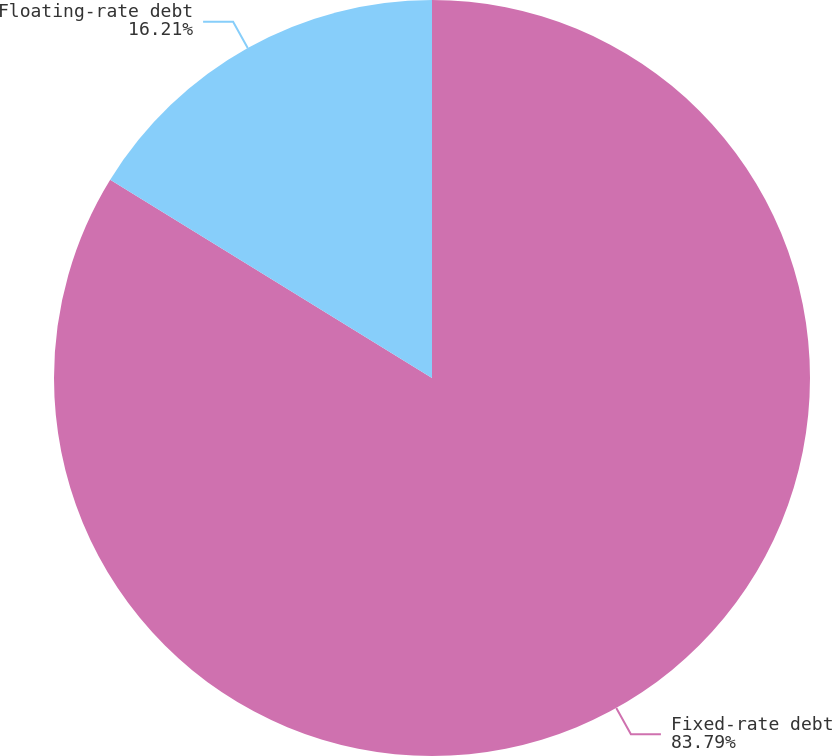<chart> <loc_0><loc_0><loc_500><loc_500><pie_chart><fcel>Fixed-rate debt<fcel>Floating-rate debt<nl><fcel>83.79%<fcel>16.21%<nl></chart> 